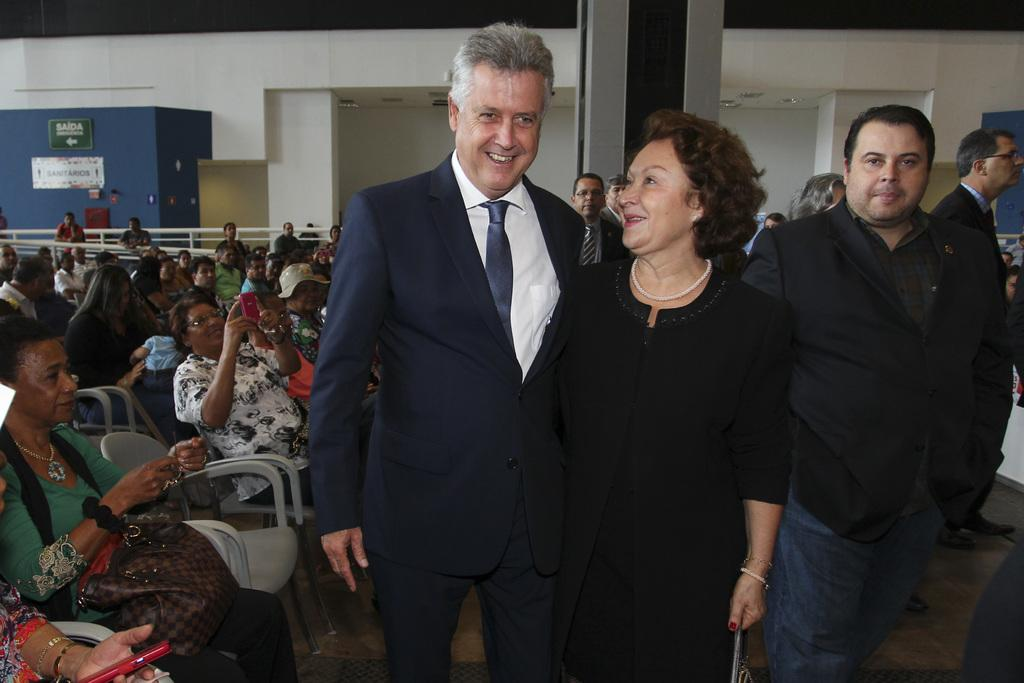Who is present in the image? There is a couple in the image. What are the couple doing in the image? Both individuals in the couple are smiling. Can you describe the setting in the background of the image? There are people sitting on chairs in the background of the image. What is the gender composition of the individuals in the image? There are men and women present in the image. What type of quilt is being used to cover the couple's eyes in the image? There is no quilt present in the image, nor is there any indication that the couple's eyes are covered. How many mouths are visible in the image? The question about mouths is not relevant to the image, as the focus is on the couple's smiling faces, not their mouths specifically. 